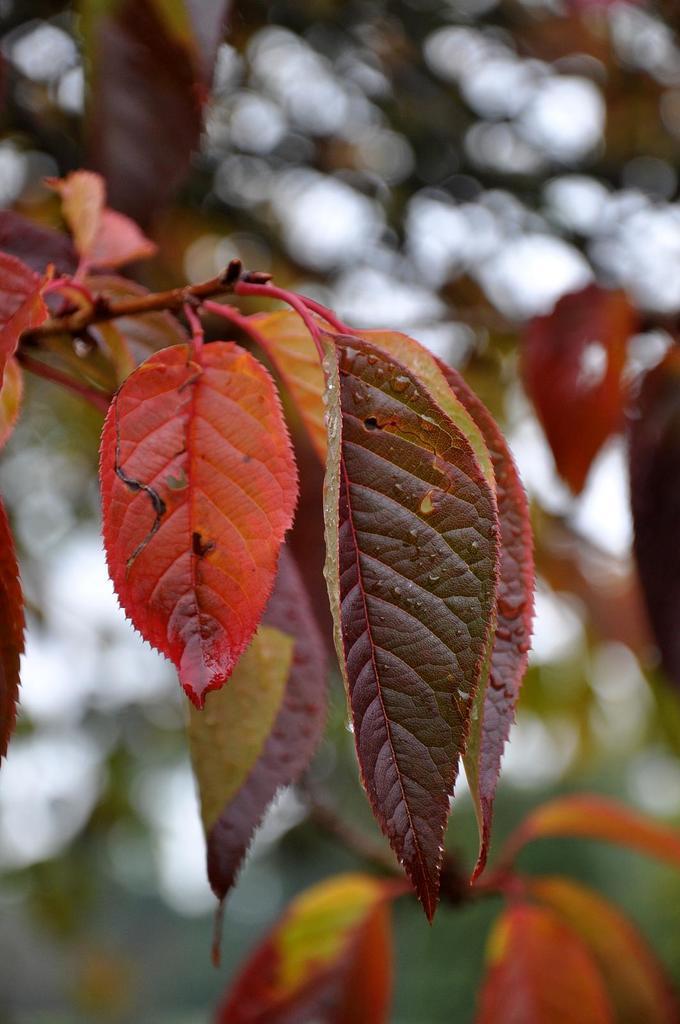Please provide a concise description of this image. In this image we can see some leaves of a tree. 